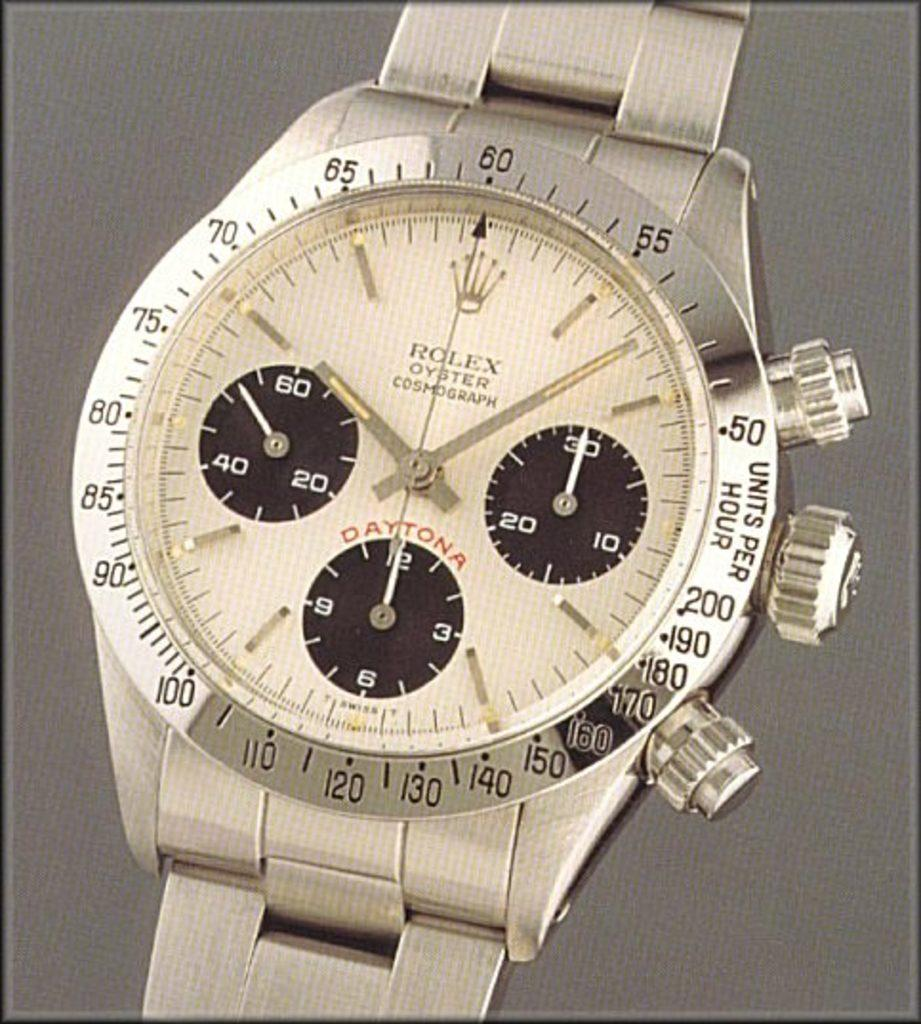<image>
Offer a succinct explanation of the picture presented. A golden Rolex watch that has the words "units per hour" on the bezel. 